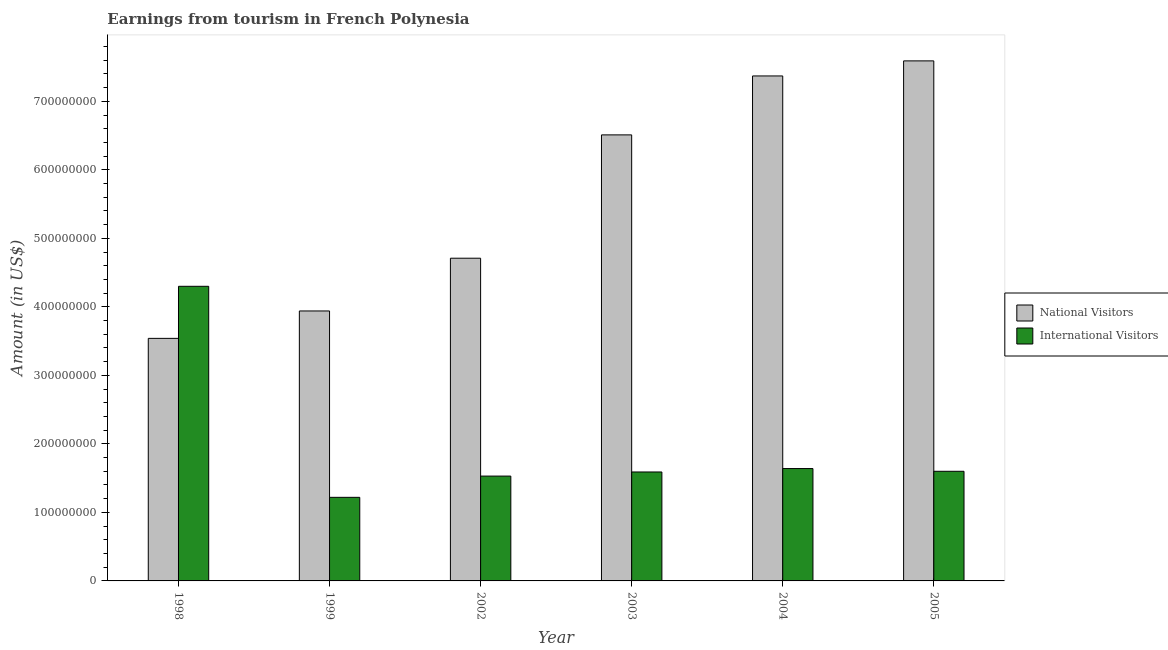How many different coloured bars are there?
Offer a very short reply. 2. How many groups of bars are there?
Your answer should be very brief. 6. Are the number of bars per tick equal to the number of legend labels?
Provide a short and direct response. Yes. How many bars are there on the 6th tick from the right?
Provide a succinct answer. 2. What is the label of the 2nd group of bars from the left?
Your answer should be compact. 1999. In how many cases, is the number of bars for a given year not equal to the number of legend labels?
Give a very brief answer. 0. What is the amount earned from national visitors in 2005?
Provide a short and direct response. 7.59e+08. Across all years, what is the maximum amount earned from national visitors?
Provide a succinct answer. 7.59e+08. Across all years, what is the minimum amount earned from national visitors?
Your response must be concise. 3.54e+08. In which year was the amount earned from international visitors maximum?
Keep it short and to the point. 1998. What is the total amount earned from national visitors in the graph?
Your response must be concise. 3.37e+09. What is the difference between the amount earned from national visitors in 2002 and that in 2003?
Ensure brevity in your answer.  -1.80e+08. What is the difference between the amount earned from international visitors in 2003 and the amount earned from national visitors in 1998?
Your response must be concise. -2.71e+08. What is the average amount earned from international visitors per year?
Provide a short and direct response. 1.98e+08. In how many years, is the amount earned from national visitors greater than 600000000 US$?
Provide a succinct answer. 3. What is the ratio of the amount earned from national visitors in 2003 to that in 2004?
Ensure brevity in your answer.  0.88. What is the difference between the highest and the second highest amount earned from international visitors?
Offer a very short reply. 2.66e+08. What is the difference between the highest and the lowest amount earned from national visitors?
Ensure brevity in your answer.  4.05e+08. In how many years, is the amount earned from international visitors greater than the average amount earned from international visitors taken over all years?
Your answer should be very brief. 1. Is the sum of the amount earned from international visitors in 2003 and 2004 greater than the maximum amount earned from national visitors across all years?
Give a very brief answer. No. What does the 2nd bar from the left in 2004 represents?
Ensure brevity in your answer.  International Visitors. What does the 2nd bar from the right in 2005 represents?
Your answer should be very brief. National Visitors. Are all the bars in the graph horizontal?
Give a very brief answer. No. Are the values on the major ticks of Y-axis written in scientific E-notation?
Offer a terse response. No. Does the graph contain any zero values?
Give a very brief answer. No. Does the graph contain grids?
Provide a short and direct response. No. Where does the legend appear in the graph?
Give a very brief answer. Center right. How many legend labels are there?
Provide a short and direct response. 2. How are the legend labels stacked?
Make the answer very short. Vertical. What is the title of the graph?
Keep it short and to the point. Earnings from tourism in French Polynesia. Does "Number of departures" appear as one of the legend labels in the graph?
Give a very brief answer. No. What is the Amount (in US$) in National Visitors in 1998?
Ensure brevity in your answer.  3.54e+08. What is the Amount (in US$) in International Visitors in 1998?
Ensure brevity in your answer.  4.30e+08. What is the Amount (in US$) in National Visitors in 1999?
Your answer should be compact. 3.94e+08. What is the Amount (in US$) of International Visitors in 1999?
Give a very brief answer. 1.22e+08. What is the Amount (in US$) in National Visitors in 2002?
Your answer should be compact. 4.71e+08. What is the Amount (in US$) of International Visitors in 2002?
Your answer should be compact. 1.53e+08. What is the Amount (in US$) of National Visitors in 2003?
Offer a terse response. 6.51e+08. What is the Amount (in US$) in International Visitors in 2003?
Give a very brief answer. 1.59e+08. What is the Amount (in US$) in National Visitors in 2004?
Your response must be concise. 7.37e+08. What is the Amount (in US$) in International Visitors in 2004?
Your answer should be compact. 1.64e+08. What is the Amount (in US$) of National Visitors in 2005?
Give a very brief answer. 7.59e+08. What is the Amount (in US$) of International Visitors in 2005?
Your response must be concise. 1.60e+08. Across all years, what is the maximum Amount (in US$) of National Visitors?
Your answer should be compact. 7.59e+08. Across all years, what is the maximum Amount (in US$) in International Visitors?
Your answer should be compact. 4.30e+08. Across all years, what is the minimum Amount (in US$) of National Visitors?
Provide a short and direct response. 3.54e+08. Across all years, what is the minimum Amount (in US$) of International Visitors?
Provide a short and direct response. 1.22e+08. What is the total Amount (in US$) of National Visitors in the graph?
Your answer should be very brief. 3.37e+09. What is the total Amount (in US$) of International Visitors in the graph?
Offer a terse response. 1.19e+09. What is the difference between the Amount (in US$) of National Visitors in 1998 and that in 1999?
Ensure brevity in your answer.  -4.00e+07. What is the difference between the Amount (in US$) of International Visitors in 1998 and that in 1999?
Make the answer very short. 3.08e+08. What is the difference between the Amount (in US$) in National Visitors in 1998 and that in 2002?
Offer a very short reply. -1.17e+08. What is the difference between the Amount (in US$) in International Visitors in 1998 and that in 2002?
Make the answer very short. 2.77e+08. What is the difference between the Amount (in US$) of National Visitors in 1998 and that in 2003?
Ensure brevity in your answer.  -2.97e+08. What is the difference between the Amount (in US$) of International Visitors in 1998 and that in 2003?
Offer a terse response. 2.71e+08. What is the difference between the Amount (in US$) of National Visitors in 1998 and that in 2004?
Your answer should be compact. -3.83e+08. What is the difference between the Amount (in US$) in International Visitors in 1998 and that in 2004?
Ensure brevity in your answer.  2.66e+08. What is the difference between the Amount (in US$) of National Visitors in 1998 and that in 2005?
Ensure brevity in your answer.  -4.05e+08. What is the difference between the Amount (in US$) of International Visitors in 1998 and that in 2005?
Offer a very short reply. 2.70e+08. What is the difference between the Amount (in US$) in National Visitors in 1999 and that in 2002?
Ensure brevity in your answer.  -7.70e+07. What is the difference between the Amount (in US$) in International Visitors in 1999 and that in 2002?
Ensure brevity in your answer.  -3.10e+07. What is the difference between the Amount (in US$) of National Visitors in 1999 and that in 2003?
Offer a terse response. -2.57e+08. What is the difference between the Amount (in US$) of International Visitors in 1999 and that in 2003?
Your answer should be very brief. -3.70e+07. What is the difference between the Amount (in US$) in National Visitors in 1999 and that in 2004?
Provide a short and direct response. -3.43e+08. What is the difference between the Amount (in US$) of International Visitors in 1999 and that in 2004?
Provide a succinct answer. -4.20e+07. What is the difference between the Amount (in US$) of National Visitors in 1999 and that in 2005?
Your response must be concise. -3.65e+08. What is the difference between the Amount (in US$) in International Visitors in 1999 and that in 2005?
Provide a short and direct response. -3.80e+07. What is the difference between the Amount (in US$) in National Visitors in 2002 and that in 2003?
Offer a terse response. -1.80e+08. What is the difference between the Amount (in US$) of International Visitors in 2002 and that in 2003?
Give a very brief answer. -6.00e+06. What is the difference between the Amount (in US$) of National Visitors in 2002 and that in 2004?
Give a very brief answer. -2.66e+08. What is the difference between the Amount (in US$) of International Visitors in 2002 and that in 2004?
Provide a short and direct response. -1.10e+07. What is the difference between the Amount (in US$) of National Visitors in 2002 and that in 2005?
Keep it short and to the point. -2.88e+08. What is the difference between the Amount (in US$) of International Visitors in 2002 and that in 2005?
Offer a very short reply. -7.00e+06. What is the difference between the Amount (in US$) in National Visitors in 2003 and that in 2004?
Your answer should be compact. -8.60e+07. What is the difference between the Amount (in US$) in International Visitors in 2003 and that in 2004?
Your response must be concise. -5.00e+06. What is the difference between the Amount (in US$) of National Visitors in 2003 and that in 2005?
Your answer should be very brief. -1.08e+08. What is the difference between the Amount (in US$) of International Visitors in 2003 and that in 2005?
Give a very brief answer. -1.00e+06. What is the difference between the Amount (in US$) of National Visitors in 2004 and that in 2005?
Ensure brevity in your answer.  -2.20e+07. What is the difference between the Amount (in US$) in International Visitors in 2004 and that in 2005?
Your answer should be very brief. 4.00e+06. What is the difference between the Amount (in US$) in National Visitors in 1998 and the Amount (in US$) in International Visitors in 1999?
Provide a short and direct response. 2.32e+08. What is the difference between the Amount (in US$) in National Visitors in 1998 and the Amount (in US$) in International Visitors in 2002?
Provide a succinct answer. 2.01e+08. What is the difference between the Amount (in US$) of National Visitors in 1998 and the Amount (in US$) of International Visitors in 2003?
Ensure brevity in your answer.  1.95e+08. What is the difference between the Amount (in US$) in National Visitors in 1998 and the Amount (in US$) in International Visitors in 2004?
Provide a short and direct response. 1.90e+08. What is the difference between the Amount (in US$) of National Visitors in 1998 and the Amount (in US$) of International Visitors in 2005?
Provide a short and direct response. 1.94e+08. What is the difference between the Amount (in US$) in National Visitors in 1999 and the Amount (in US$) in International Visitors in 2002?
Your response must be concise. 2.41e+08. What is the difference between the Amount (in US$) of National Visitors in 1999 and the Amount (in US$) of International Visitors in 2003?
Offer a terse response. 2.35e+08. What is the difference between the Amount (in US$) of National Visitors in 1999 and the Amount (in US$) of International Visitors in 2004?
Provide a succinct answer. 2.30e+08. What is the difference between the Amount (in US$) in National Visitors in 1999 and the Amount (in US$) in International Visitors in 2005?
Make the answer very short. 2.34e+08. What is the difference between the Amount (in US$) of National Visitors in 2002 and the Amount (in US$) of International Visitors in 2003?
Give a very brief answer. 3.12e+08. What is the difference between the Amount (in US$) of National Visitors in 2002 and the Amount (in US$) of International Visitors in 2004?
Keep it short and to the point. 3.07e+08. What is the difference between the Amount (in US$) of National Visitors in 2002 and the Amount (in US$) of International Visitors in 2005?
Give a very brief answer. 3.11e+08. What is the difference between the Amount (in US$) in National Visitors in 2003 and the Amount (in US$) in International Visitors in 2004?
Provide a succinct answer. 4.87e+08. What is the difference between the Amount (in US$) of National Visitors in 2003 and the Amount (in US$) of International Visitors in 2005?
Make the answer very short. 4.91e+08. What is the difference between the Amount (in US$) of National Visitors in 2004 and the Amount (in US$) of International Visitors in 2005?
Provide a succinct answer. 5.77e+08. What is the average Amount (in US$) in National Visitors per year?
Ensure brevity in your answer.  5.61e+08. What is the average Amount (in US$) of International Visitors per year?
Ensure brevity in your answer.  1.98e+08. In the year 1998, what is the difference between the Amount (in US$) of National Visitors and Amount (in US$) of International Visitors?
Provide a short and direct response. -7.60e+07. In the year 1999, what is the difference between the Amount (in US$) of National Visitors and Amount (in US$) of International Visitors?
Offer a very short reply. 2.72e+08. In the year 2002, what is the difference between the Amount (in US$) in National Visitors and Amount (in US$) in International Visitors?
Make the answer very short. 3.18e+08. In the year 2003, what is the difference between the Amount (in US$) in National Visitors and Amount (in US$) in International Visitors?
Provide a succinct answer. 4.92e+08. In the year 2004, what is the difference between the Amount (in US$) in National Visitors and Amount (in US$) in International Visitors?
Provide a succinct answer. 5.73e+08. In the year 2005, what is the difference between the Amount (in US$) of National Visitors and Amount (in US$) of International Visitors?
Your response must be concise. 5.99e+08. What is the ratio of the Amount (in US$) in National Visitors in 1998 to that in 1999?
Keep it short and to the point. 0.9. What is the ratio of the Amount (in US$) of International Visitors in 1998 to that in 1999?
Give a very brief answer. 3.52. What is the ratio of the Amount (in US$) of National Visitors in 1998 to that in 2002?
Keep it short and to the point. 0.75. What is the ratio of the Amount (in US$) in International Visitors in 1998 to that in 2002?
Your answer should be very brief. 2.81. What is the ratio of the Amount (in US$) of National Visitors in 1998 to that in 2003?
Keep it short and to the point. 0.54. What is the ratio of the Amount (in US$) of International Visitors in 1998 to that in 2003?
Provide a short and direct response. 2.7. What is the ratio of the Amount (in US$) in National Visitors in 1998 to that in 2004?
Your response must be concise. 0.48. What is the ratio of the Amount (in US$) of International Visitors in 1998 to that in 2004?
Offer a terse response. 2.62. What is the ratio of the Amount (in US$) of National Visitors in 1998 to that in 2005?
Offer a terse response. 0.47. What is the ratio of the Amount (in US$) of International Visitors in 1998 to that in 2005?
Your answer should be very brief. 2.69. What is the ratio of the Amount (in US$) in National Visitors in 1999 to that in 2002?
Make the answer very short. 0.84. What is the ratio of the Amount (in US$) of International Visitors in 1999 to that in 2002?
Provide a succinct answer. 0.8. What is the ratio of the Amount (in US$) in National Visitors in 1999 to that in 2003?
Make the answer very short. 0.61. What is the ratio of the Amount (in US$) of International Visitors in 1999 to that in 2003?
Provide a short and direct response. 0.77. What is the ratio of the Amount (in US$) of National Visitors in 1999 to that in 2004?
Provide a short and direct response. 0.53. What is the ratio of the Amount (in US$) in International Visitors in 1999 to that in 2004?
Your answer should be compact. 0.74. What is the ratio of the Amount (in US$) of National Visitors in 1999 to that in 2005?
Give a very brief answer. 0.52. What is the ratio of the Amount (in US$) in International Visitors in 1999 to that in 2005?
Provide a succinct answer. 0.76. What is the ratio of the Amount (in US$) in National Visitors in 2002 to that in 2003?
Your answer should be compact. 0.72. What is the ratio of the Amount (in US$) in International Visitors in 2002 to that in 2003?
Make the answer very short. 0.96. What is the ratio of the Amount (in US$) in National Visitors in 2002 to that in 2004?
Your answer should be compact. 0.64. What is the ratio of the Amount (in US$) of International Visitors in 2002 to that in 2004?
Ensure brevity in your answer.  0.93. What is the ratio of the Amount (in US$) of National Visitors in 2002 to that in 2005?
Your response must be concise. 0.62. What is the ratio of the Amount (in US$) of International Visitors in 2002 to that in 2005?
Your answer should be very brief. 0.96. What is the ratio of the Amount (in US$) in National Visitors in 2003 to that in 2004?
Ensure brevity in your answer.  0.88. What is the ratio of the Amount (in US$) in International Visitors in 2003 to that in 2004?
Give a very brief answer. 0.97. What is the ratio of the Amount (in US$) in National Visitors in 2003 to that in 2005?
Your answer should be very brief. 0.86. What is the difference between the highest and the second highest Amount (in US$) in National Visitors?
Keep it short and to the point. 2.20e+07. What is the difference between the highest and the second highest Amount (in US$) of International Visitors?
Provide a short and direct response. 2.66e+08. What is the difference between the highest and the lowest Amount (in US$) in National Visitors?
Make the answer very short. 4.05e+08. What is the difference between the highest and the lowest Amount (in US$) in International Visitors?
Keep it short and to the point. 3.08e+08. 